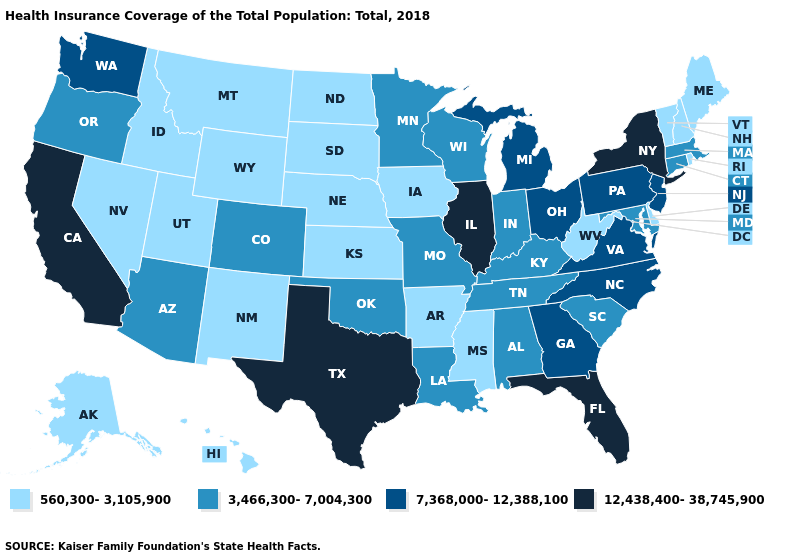What is the value of New Mexico?
Quick response, please. 560,300-3,105,900. Name the states that have a value in the range 3,466,300-7,004,300?
Short answer required. Alabama, Arizona, Colorado, Connecticut, Indiana, Kentucky, Louisiana, Maryland, Massachusetts, Minnesota, Missouri, Oklahoma, Oregon, South Carolina, Tennessee, Wisconsin. Name the states that have a value in the range 7,368,000-12,388,100?
Give a very brief answer. Georgia, Michigan, New Jersey, North Carolina, Ohio, Pennsylvania, Virginia, Washington. Name the states that have a value in the range 560,300-3,105,900?
Be succinct. Alaska, Arkansas, Delaware, Hawaii, Idaho, Iowa, Kansas, Maine, Mississippi, Montana, Nebraska, Nevada, New Hampshire, New Mexico, North Dakota, Rhode Island, South Dakota, Utah, Vermont, West Virginia, Wyoming. Name the states that have a value in the range 560,300-3,105,900?
Write a very short answer. Alaska, Arkansas, Delaware, Hawaii, Idaho, Iowa, Kansas, Maine, Mississippi, Montana, Nebraska, Nevada, New Hampshire, New Mexico, North Dakota, Rhode Island, South Dakota, Utah, Vermont, West Virginia, Wyoming. Does Michigan have the highest value in the MidWest?
Keep it brief. No. What is the lowest value in the MidWest?
Concise answer only. 560,300-3,105,900. Name the states that have a value in the range 560,300-3,105,900?
Be succinct. Alaska, Arkansas, Delaware, Hawaii, Idaho, Iowa, Kansas, Maine, Mississippi, Montana, Nebraska, Nevada, New Hampshire, New Mexico, North Dakota, Rhode Island, South Dakota, Utah, Vermont, West Virginia, Wyoming. Among the states that border South Dakota , which have the highest value?
Answer briefly. Minnesota. Name the states that have a value in the range 3,466,300-7,004,300?
Concise answer only. Alabama, Arizona, Colorado, Connecticut, Indiana, Kentucky, Louisiana, Maryland, Massachusetts, Minnesota, Missouri, Oklahoma, Oregon, South Carolina, Tennessee, Wisconsin. What is the value of Wyoming?
Concise answer only. 560,300-3,105,900. Does the map have missing data?
Concise answer only. No. Which states hav the highest value in the South?
Keep it brief. Florida, Texas. What is the value of Wyoming?
Quick response, please. 560,300-3,105,900. Name the states that have a value in the range 560,300-3,105,900?
Give a very brief answer. Alaska, Arkansas, Delaware, Hawaii, Idaho, Iowa, Kansas, Maine, Mississippi, Montana, Nebraska, Nevada, New Hampshire, New Mexico, North Dakota, Rhode Island, South Dakota, Utah, Vermont, West Virginia, Wyoming. 